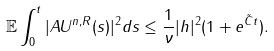<formula> <loc_0><loc_0><loc_500><loc_500>\mathbb { E } \int _ { 0 } ^ { t } | A U ^ { n , R } ( s ) | ^ { 2 } d s \leq \frac { 1 } { \nu } | h | ^ { 2 } ( 1 + e ^ { \tilde { C } t } ) .</formula> 